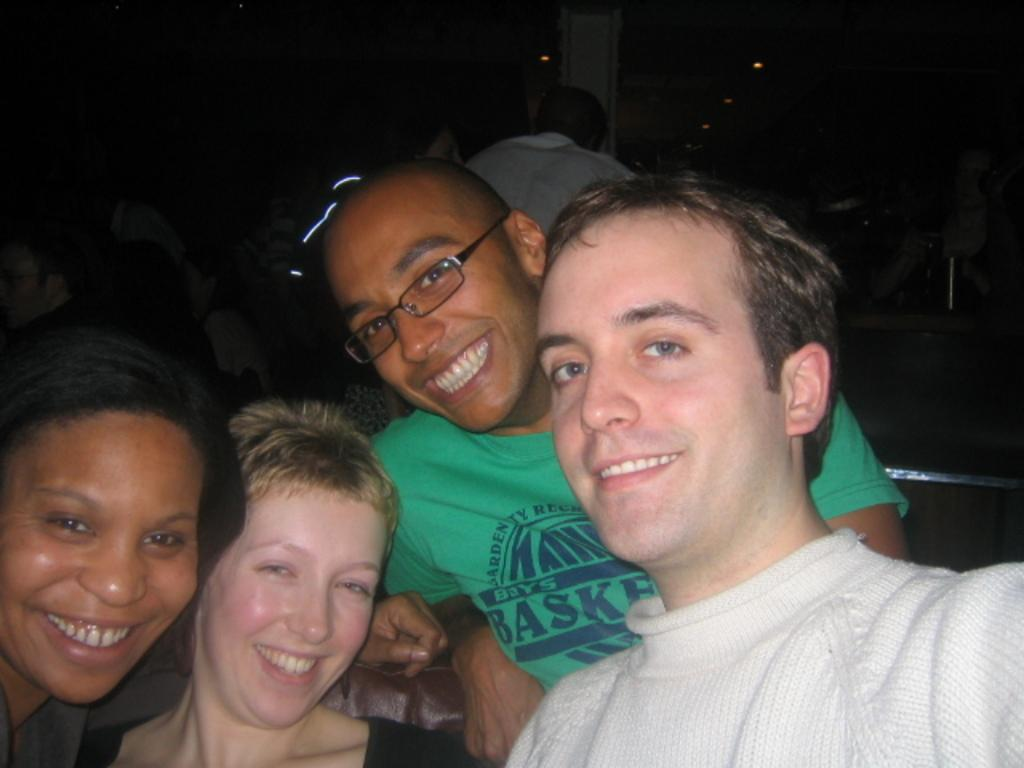What is the general expression of the persons in the image? The persons in the image are smiling. Can you describe any specific features of one of the persons? One of the persons is wearing spectacles. Are there any other persons visible in the image besides the ones in the foreground? Yes, there are persons visible in the background of the image. How would you describe the lighting or color of the background in the image? The background of the image is dark. What type of coal is being used by the persons in the image? There is no coal present in the image; it features persons smiling and wearing spectacles. How many cats can be seen interacting with the persons in the image? There are no cats present in the image. 